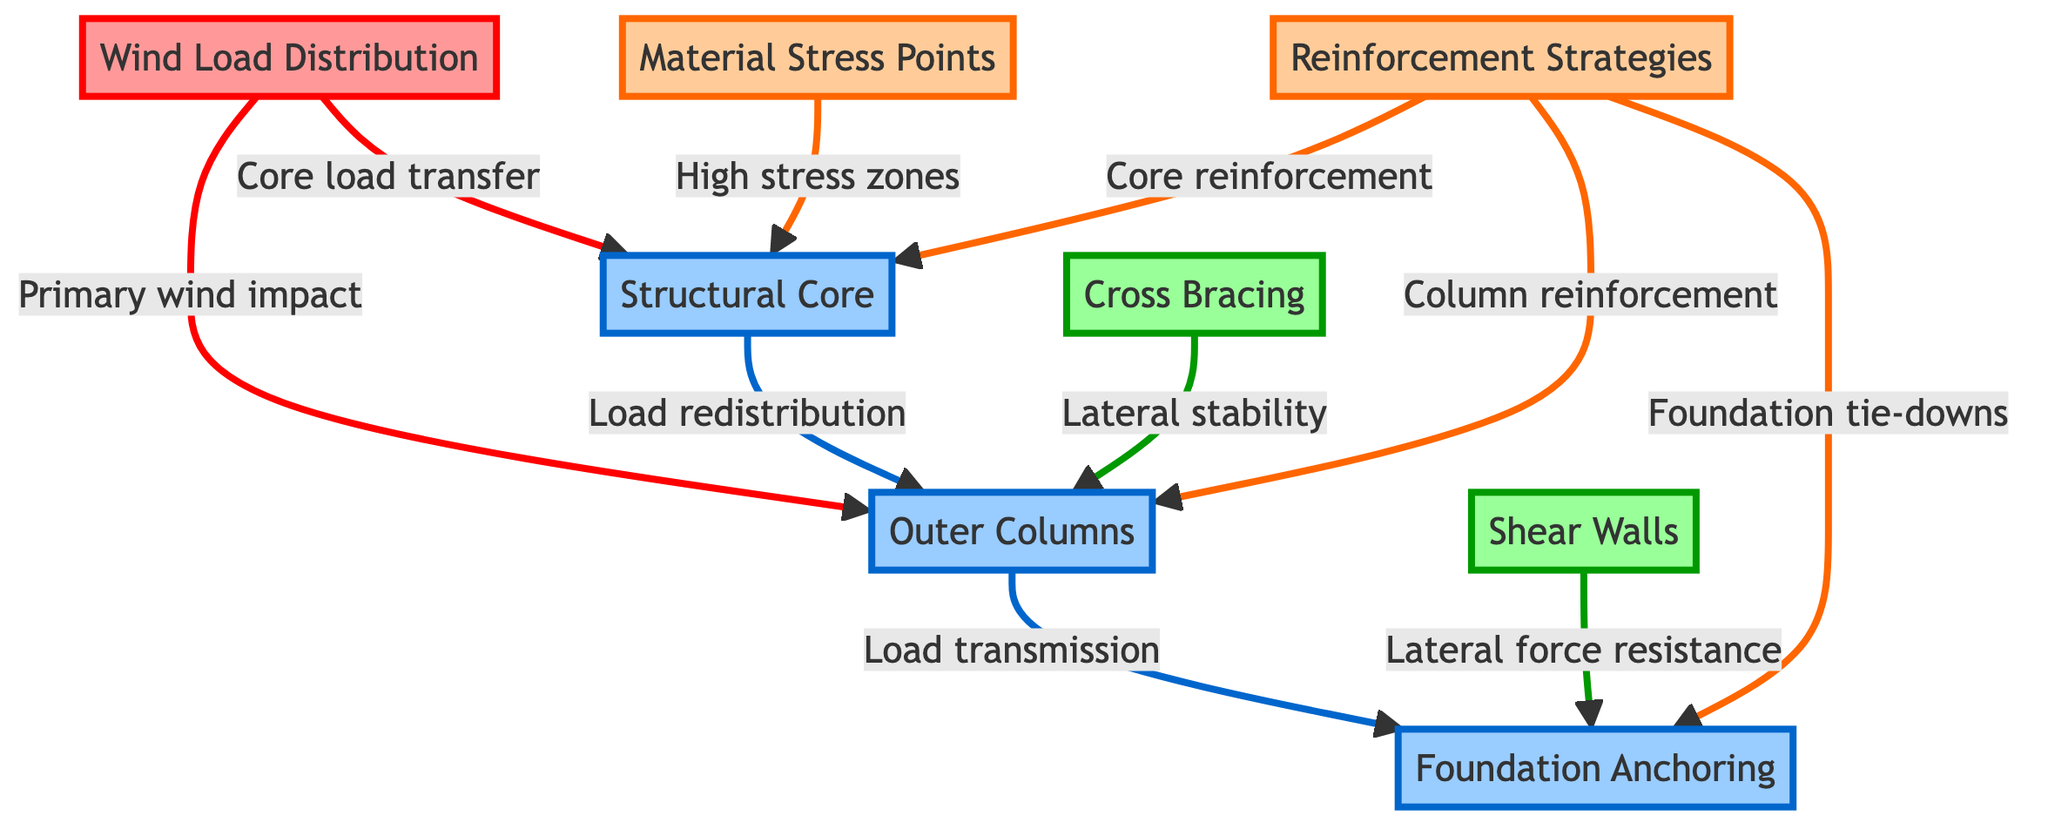What does the wind load act on? The diagram shows that the wind load acts on both the outer columns and the structural core. This is illustrated by the arrows indicating the direction of the load distribution towards these structural elements.
Answer: outer columns, structural core How many primary load transfer connections are represented in the diagram? The diagram has three primary load transfer connections: wind load to outer columns, wind load to structural core, and structural core to outer columns. Each of these connections is represented by directional arrows showing the flow of load.
Answer: 3 What is the role of cross bracing in the diagram? Cross bracing is illustrated in the diagram with an arrow pointing to the outer columns, indicating it contributes to lateral stability. This means its role is to enhance the stability of the structure against lateral forces, which is crucial in hurricane conditions.
Answer: Lateral stability Which structures provide lateral force resistance? The diagram indicates that shear walls provide lateral force resistance, shown by the directional arrow linking it to the foundation. This implies that shear walls are essential for maintaining structural integrity against lateral pressures from winds.
Answer: Shear Walls What material stress points are indicated in the structural core? The diagram labels material usage as related to high stress zones within the structural core, showing that this area experiences significant stress due to load distribution, particularly from the wind loads.
Answer: High stress zones What type of reinforcement is applied to the foundation? The diagram specifies foundation tie-downs as the reinforcement strategy applied to the foundation. This indicates it is a critical strategy for anchoring the structure securely against uplift forces caused by strong winds.
Answer: Foundation tie-downs What elements are involved in load redistribution to the outer columns? The diagram indicates that the structural core is responsible for load redistribution to the outer columns. The arrows show that load goes from the structural core to the outer columns, signifying the transfer of forces.
Answer: Structural Core What are the support structures in the diagram? The diagram displays cross bracing and shear walls as the support structures indicated by arrows connecting them to the outer columns and foundation. This shows they play a vital role in structural support, especially during high wind events.
Answer: Cross Bracing, Shear Walls How does the reinforcement strategy affect the structural core? The diagram shows that reinforcement strategies specifically enhance the structural integrity of the core by indicating connection arrows towards it. This means that reinforcing elements are designed to increase the load-carrying capacity and safety of this critical component.
Answer: Core reinforcement 